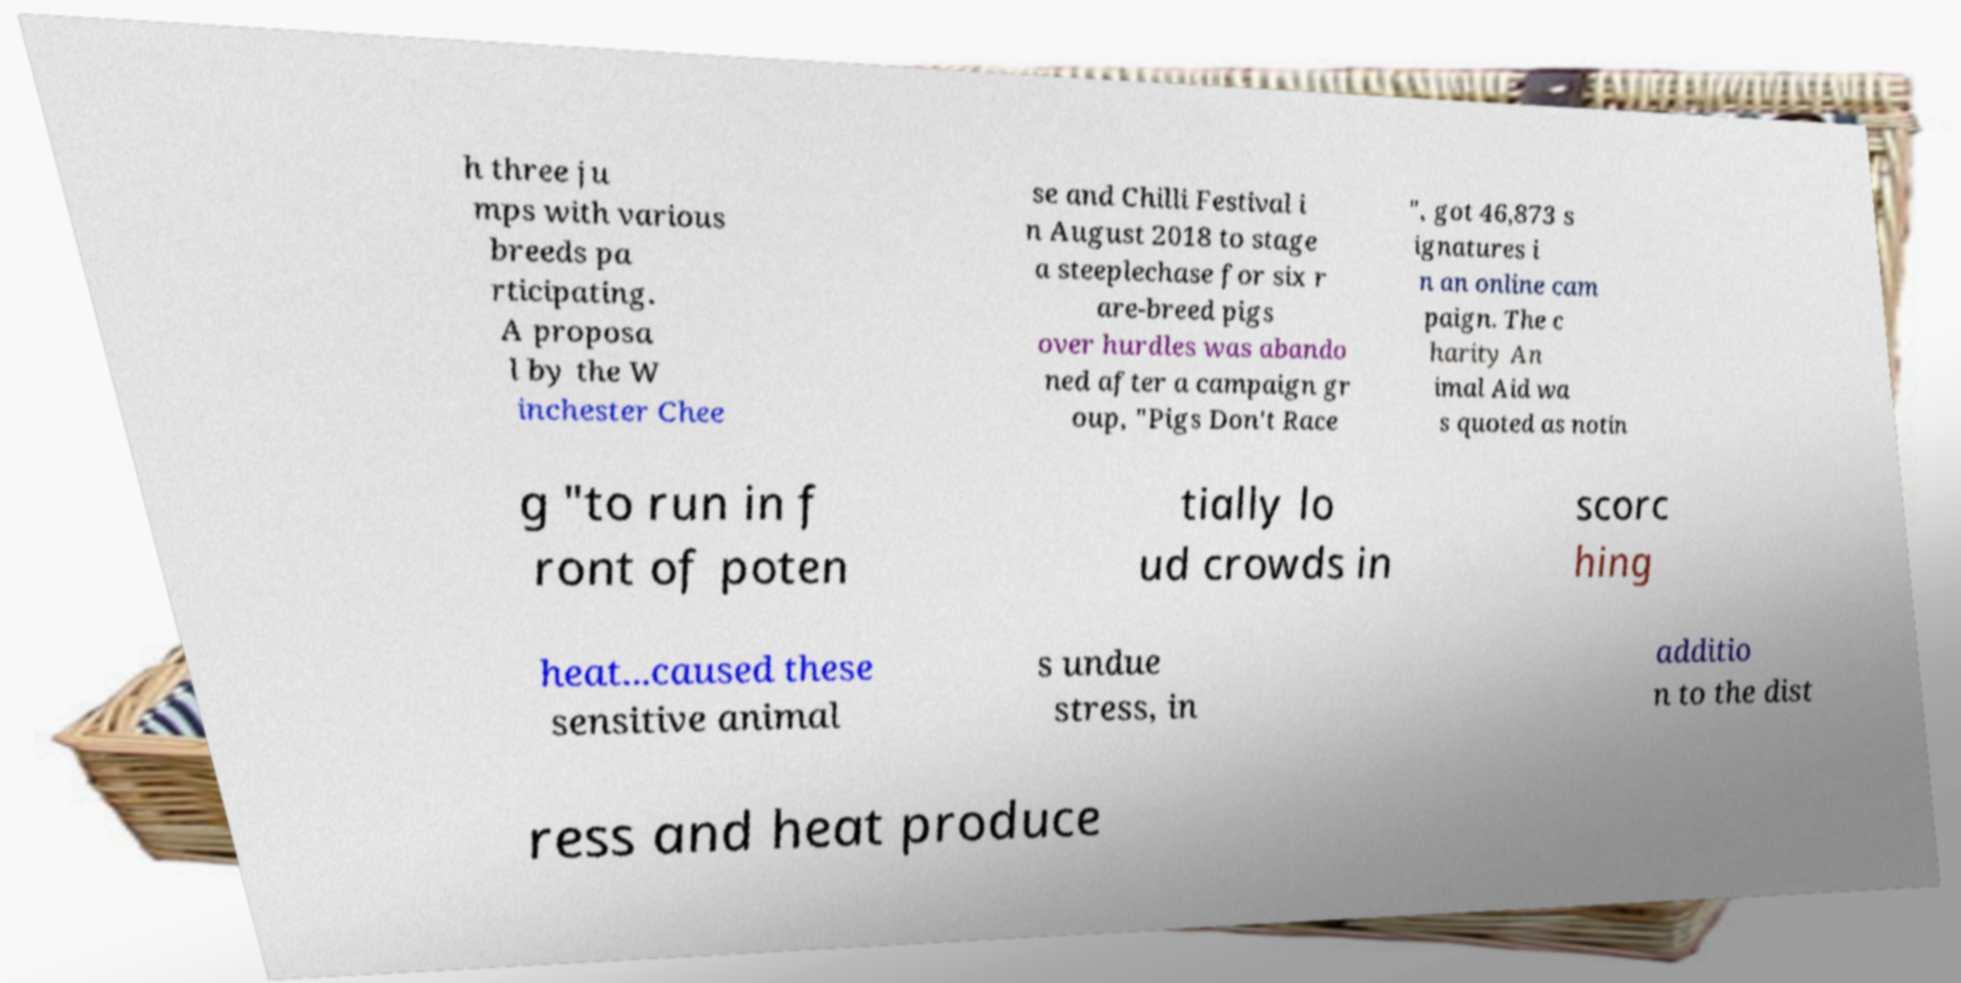Could you extract and type out the text from this image? h three ju mps with various breeds pa rticipating. A proposa l by the W inchester Chee se and Chilli Festival i n August 2018 to stage a steeplechase for six r are-breed pigs over hurdles was abando ned after a campaign gr oup, "Pigs Don't Race ", got 46,873 s ignatures i n an online cam paign. The c harity An imal Aid wa s quoted as notin g "to run in f ront of poten tially lo ud crowds in scorc hing heat...caused these sensitive animal s undue stress, in additio n to the dist ress and heat produce 